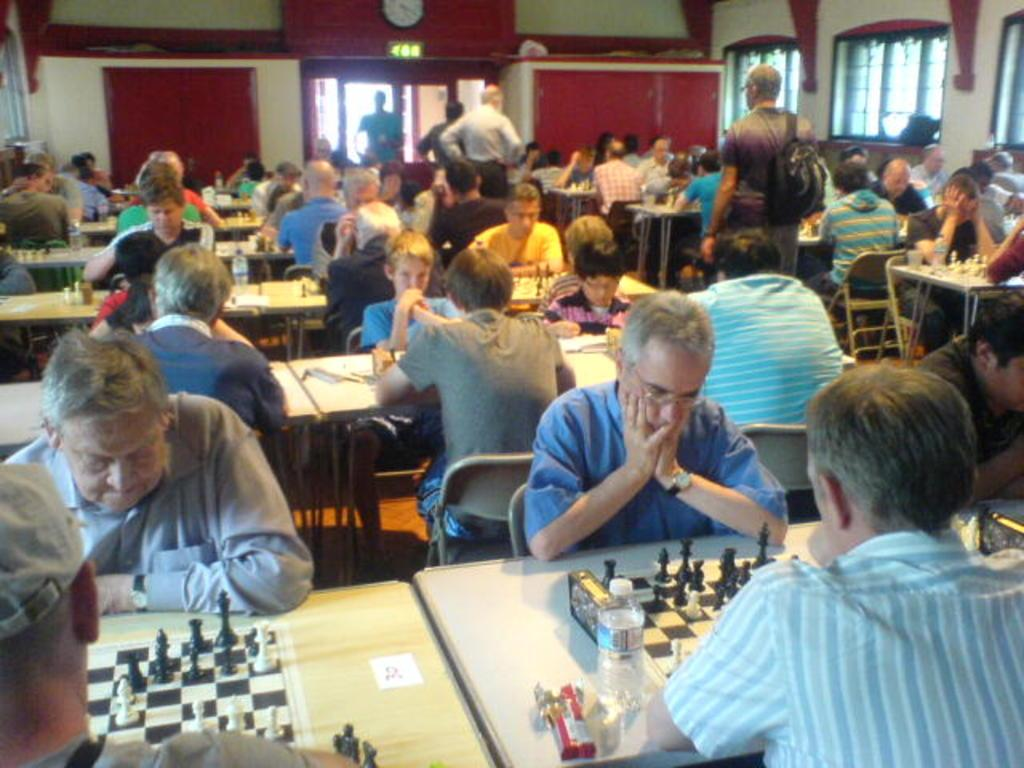What is the color of the wall in the image? The wall in the image is white. What are the people in the image doing? The people in the image are standing and sitting. What is on the table in the image? There is a table in the image with chess boards, coins, and a bottle on it. Can you tell me how many geese are on the table in the image? There are no geese present in the image; the table has chess boards, coins, and a bottle on it. What type of crayon is being used for payment in the image? There is no crayon or payment activity present in the image. 